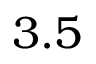<formula> <loc_0><loc_0><loc_500><loc_500>3 . 5</formula> 